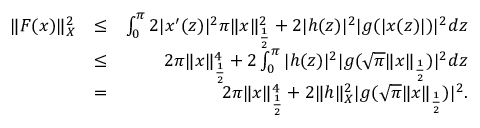Convert formula to latex. <formula><loc_0><loc_0><loc_500><loc_500>\begin{array} { r l r } { \| F ( x ) \| _ { X } ^ { 2 } } & { \leq } & { \int _ { 0 } ^ { \pi } 2 | x ^ { \prime } ( z ) | ^ { 2 } \pi \| x \| _ { \frac { 1 } { 2 } } ^ { 2 } + 2 | h ( z ) | ^ { 2 } | g ( | x ( z ) | ) | ^ { 2 } d z } \\ & { \leq } & { 2 \pi \| x \| _ { \frac { 1 } { 2 } } ^ { 4 } + 2 \int _ { 0 } ^ { \pi } | h ( z ) | ^ { 2 } | g ( \sqrt { \pi } \| x \| _ { \frac { 1 } { 2 } } ) | ^ { 2 } d z } \\ & { = } & { 2 \pi \| x \| _ { \frac { 1 } { 2 } } ^ { 4 } + 2 \| h \| _ { X } ^ { 2 } | g ( \sqrt { \pi } \| x \| _ { \frac { 1 } { 2 } } ) | ^ { 2 } . } \end{array}</formula> 